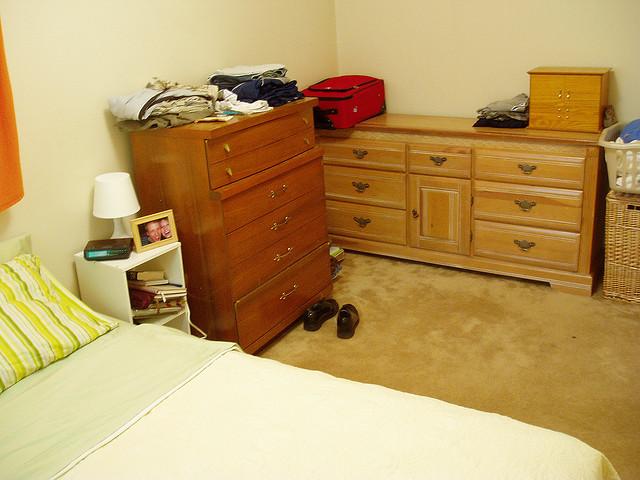Is there a clock on the side table?
Short answer required. Yes. Where is the framed photo?
Keep it brief. One night stand. How many dressers are there?
Quick response, please. 2. 